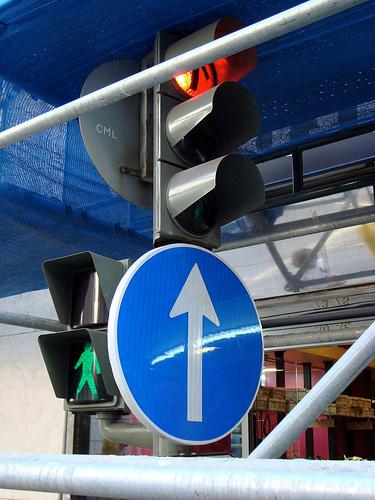Question: what is blue and white?
Choices:
A. A sign.
B. Cup.
C. Building.
D. Car.
Answer with the letter. Answer: A Question: where is an arrow pointing?
Choices:
A. Down.
B. Left.
C. Right.
D. Up.
Answer with the letter. Answer: D Question: what is pointing upwards?
Choices:
A. A hand.
B. An arrow.
C. A leg.
D. A gun.
Answer with the letter. Answer: B Question: what is lit green?
Choices:
A. A traffic light.
B. A neon sign.
C. A button.
D. The tv.
Answer with the letter. Answer: A Question: where was the photo taken?
Choices:
A. Living room.
B. Club.
C. Kitchen.
D. On the street.
Answer with the letter. Answer: D Question: what is lit red?
Choices:
A. Traffic light.
B. Stop sign.
C. Brake lights.
D. The button.
Answer with the letter. Answer: A 